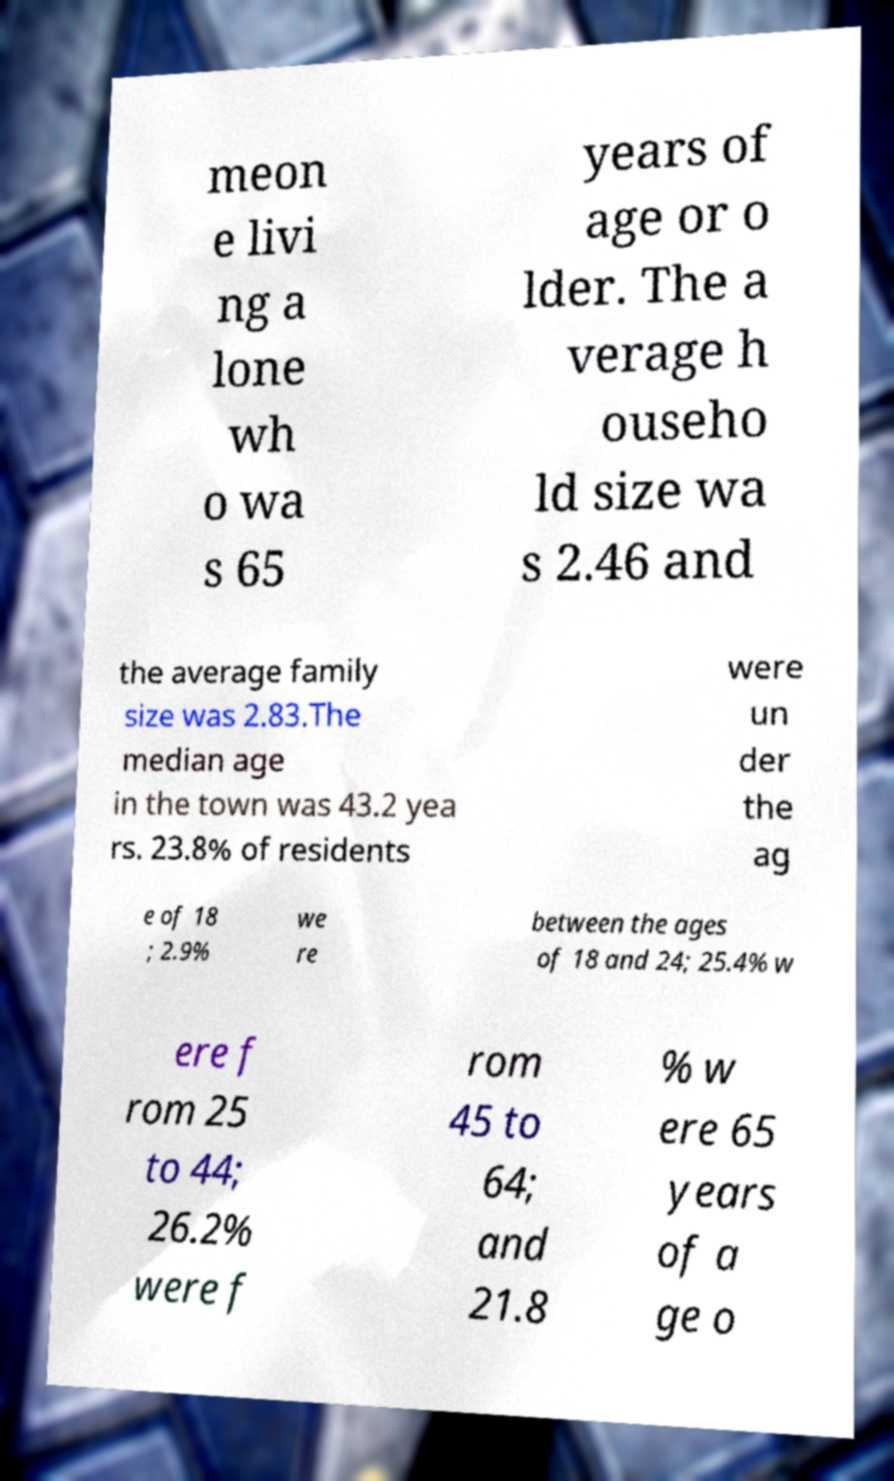Could you assist in decoding the text presented in this image and type it out clearly? meon e livi ng a lone wh o wa s 65 years of age or o lder. The a verage h ouseho ld size wa s 2.46 and the average family size was 2.83.The median age in the town was 43.2 yea rs. 23.8% of residents were un der the ag e of 18 ; 2.9% we re between the ages of 18 and 24; 25.4% w ere f rom 25 to 44; 26.2% were f rom 45 to 64; and 21.8 % w ere 65 years of a ge o 